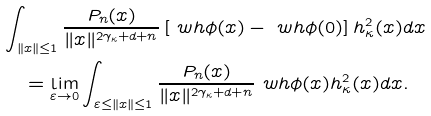<formula> <loc_0><loc_0><loc_500><loc_500>& \int _ { \| x \| \leq 1 } \frac { P _ { n } ( x ) } { \| x \| ^ { 2 \gamma _ { \kappa } + d + n } } \left [ \ w h \phi ( x ) - \ w h \phi ( 0 ) \right ] h _ { \kappa } ^ { 2 } ( x ) d x \\ & \quad = \lim _ { \varepsilon \to 0 } \int _ { \varepsilon \leq \| x \| \leq 1 } \frac { P _ { n } ( x ) } { \| x \| ^ { 2 \gamma _ { \kappa } + d + n } } \ w h \phi ( x ) h _ { \kappa } ^ { 2 } ( x ) d x .</formula> 